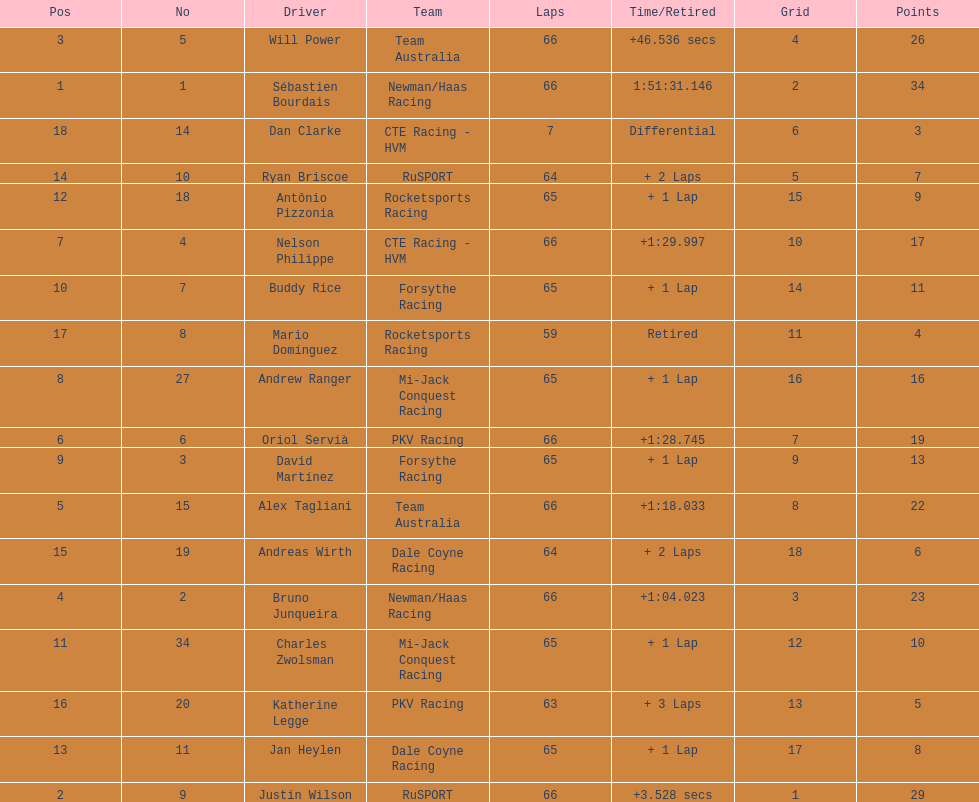At the 2006 gran premio telmex, how many drivers completed less than 60 laps? 2. I'm looking to parse the entire table for insights. Could you assist me with that? {'header': ['Pos', 'No', 'Driver', 'Team', 'Laps', 'Time/Retired', 'Grid', 'Points'], 'rows': [['3', '5', 'Will Power', 'Team Australia', '66', '+46.536 secs', '4', '26'], ['1', '1', 'Sébastien Bourdais', 'Newman/Haas Racing', '66', '1:51:31.146', '2', '34'], ['18', '14', 'Dan Clarke', 'CTE Racing - HVM', '7', 'Differential', '6', '3'], ['14', '10', 'Ryan Briscoe', 'RuSPORT', '64', '+ 2 Laps', '5', '7'], ['12', '18', 'Antônio Pizzonia', 'Rocketsports Racing', '65', '+ 1 Lap', '15', '9'], ['7', '4', 'Nelson Philippe', 'CTE Racing - HVM', '66', '+1:29.997', '10', '17'], ['10', '7', 'Buddy Rice', 'Forsythe Racing', '65', '+ 1 Lap', '14', '11'], ['17', '8', 'Mario Domínguez', 'Rocketsports Racing', '59', 'Retired', '11', '4'], ['8', '27', 'Andrew Ranger', 'Mi-Jack Conquest Racing', '65', '+ 1 Lap', '16', '16'], ['6', '6', 'Oriol Servià', 'PKV Racing', '66', '+1:28.745', '7', '19'], ['9', '3', 'David Martínez', 'Forsythe Racing', '65', '+ 1 Lap', '9', '13'], ['5', '15', 'Alex Tagliani', 'Team Australia', '66', '+1:18.033', '8', '22'], ['15', '19', 'Andreas Wirth', 'Dale Coyne Racing', '64', '+ 2 Laps', '18', '6'], ['4', '2', 'Bruno Junqueira', 'Newman/Haas Racing', '66', '+1:04.023', '3', '23'], ['11', '34', 'Charles Zwolsman', 'Mi-Jack Conquest Racing', '65', '+ 1 Lap', '12', '10'], ['16', '20', 'Katherine Legge', 'PKV Racing', '63', '+ 3 Laps', '13', '5'], ['13', '11', 'Jan Heylen', 'Dale Coyne Racing', '65', '+ 1 Lap', '17', '8'], ['2', '9', 'Justin Wilson', 'RuSPORT', '66', '+3.528 secs', '1', '29']]} 